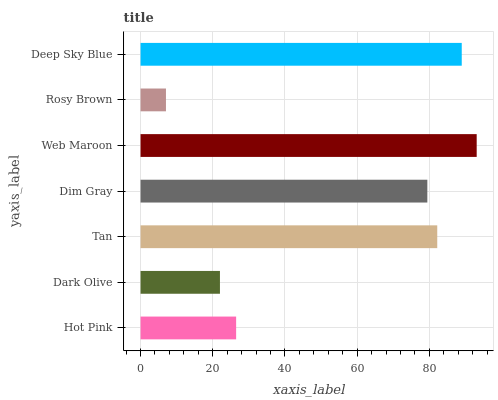Is Rosy Brown the minimum?
Answer yes or no. Yes. Is Web Maroon the maximum?
Answer yes or no. Yes. Is Dark Olive the minimum?
Answer yes or no. No. Is Dark Olive the maximum?
Answer yes or no. No. Is Hot Pink greater than Dark Olive?
Answer yes or no. Yes. Is Dark Olive less than Hot Pink?
Answer yes or no. Yes. Is Dark Olive greater than Hot Pink?
Answer yes or no. No. Is Hot Pink less than Dark Olive?
Answer yes or no. No. Is Dim Gray the high median?
Answer yes or no. Yes. Is Dim Gray the low median?
Answer yes or no. Yes. Is Web Maroon the high median?
Answer yes or no. No. Is Rosy Brown the low median?
Answer yes or no. No. 